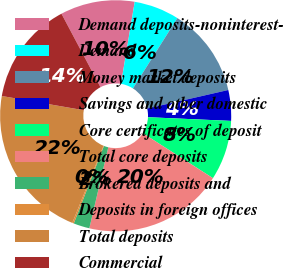Convert chart to OTSL. <chart><loc_0><loc_0><loc_500><loc_500><pie_chart><fcel>Demand deposits-noninterest-<fcel>Demand<fcel>Money market deposits<fcel>Savings and other domestic<fcel>Core certificates of deposit<fcel>Total core deposits<fcel>Brokered deposits and<fcel>Deposits in foreign offices<fcel>Total deposits<fcel>Commercial<nl><fcel>10.41%<fcel>6.33%<fcel>12.45%<fcel>4.29%<fcel>8.37%<fcel>19.58%<fcel>2.25%<fcel>0.21%<fcel>21.62%<fcel>14.49%<nl></chart> 